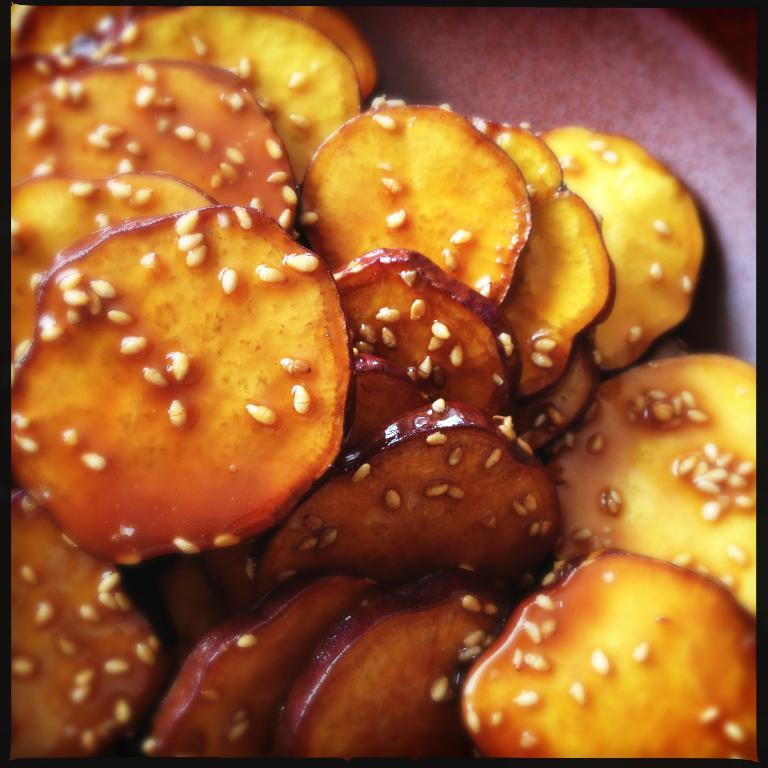What type of eggnog is being exchanged between the sticks in the image? There is no eggnog or sticks present in the image, so it is not possible to answer that question. 